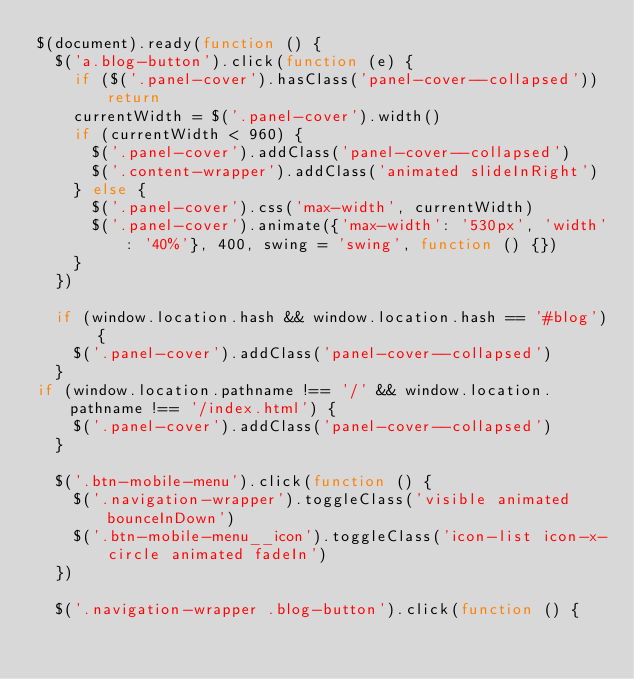Convert code to text. <code><loc_0><loc_0><loc_500><loc_500><_JavaScript_>$(document).ready(function () {
  $('a.blog-button').click(function (e) {
    if ($('.panel-cover').hasClass('panel-cover--collapsed')) return
    currentWidth = $('.panel-cover').width()
    if (currentWidth < 960) {
      $('.panel-cover').addClass('panel-cover--collapsed')
      $('.content-wrapper').addClass('animated slideInRight')
    } else {
      $('.panel-cover').css('max-width', currentWidth)
      $('.panel-cover').animate({'max-width': '530px', 'width': '40%'}, 400, swing = 'swing', function () {})
    }
  })

  if (window.location.hash && window.location.hash == '#blog') {
    $('.panel-cover').addClass('panel-cover--collapsed')
  }
if (window.location.pathname !== '/' && window.location.pathname !== '/index.html') {
    $('.panel-cover').addClass('panel-cover--collapsed')
  }

  $('.btn-mobile-menu').click(function () {
    $('.navigation-wrapper').toggleClass('visible animated bounceInDown')
    $('.btn-mobile-menu__icon').toggleClass('icon-list icon-x-circle animated fadeIn')
  })

  $('.navigation-wrapper .blog-button').click(function () {</code> 